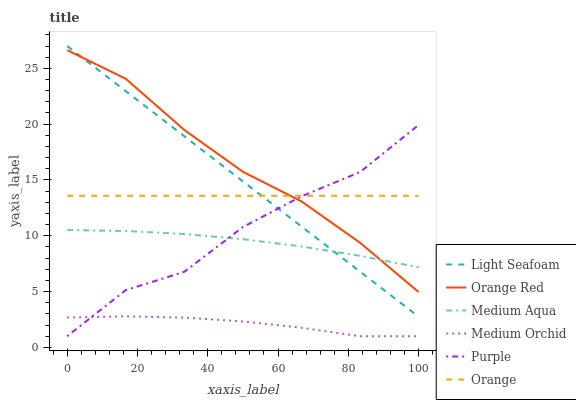Does Medium Orchid have the minimum area under the curve?
Answer yes or no. Yes. Does Orange Red have the maximum area under the curve?
Answer yes or no. Yes. Does Medium Aqua have the minimum area under the curve?
Answer yes or no. No. Does Medium Aqua have the maximum area under the curve?
Answer yes or no. No. Is Light Seafoam the smoothest?
Answer yes or no. Yes. Is Purple the roughest?
Answer yes or no. Yes. Is Medium Orchid the smoothest?
Answer yes or no. No. Is Medium Orchid the roughest?
Answer yes or no. No. Does Purple have the lowest value?
Answer yes or no. Yes. Does Medium Aqua have the lowest value?
Answer yes or no. No. Does Light Seafoam have the highest value?
Answer yes or no. Yes. Does Medium Aqua have the highest value?
Answer yes or no. No. Is Medium Orchid less than Orange Red?
Answer yes or no. Yes. Is Light Seafoam greater than Medium Orchid?
Answer yes or no. Yes. Does Medium Orchid intersect Purple?
Answer yes or no. Yes. Is Medium Orchid less than Purple?
Answer yes or no. No. Is Medium Orchid greater than Purple?
Answer yes or no. No. Does Medium Orchid intersect Orange Red?
Answer yes or no. No. 